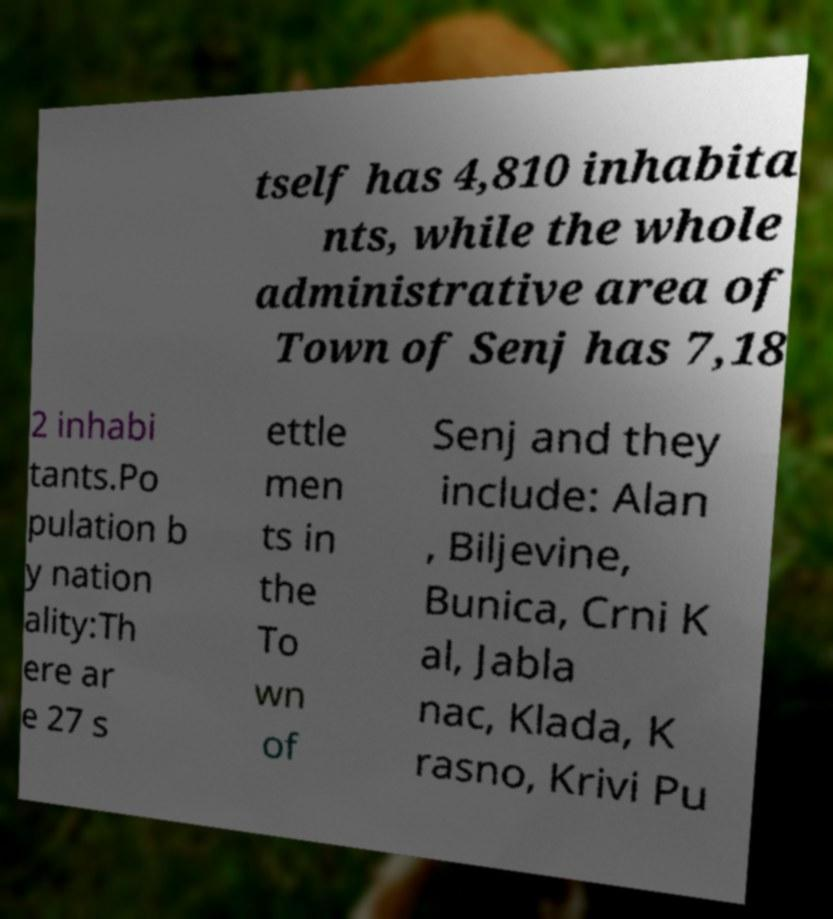Can you accurately transcribe the text from the provided image for me? tself has 4,810 inhabita nts, while the whole administrative area of Town of Senj has 7,18 2 inhabi tants.Po pulation b y nation ality:Th ere ar e 27 s ettle men ts in the To wn of Senj and they include: Alan , Biljevine, Bunica, Crni K al, Jabla nac, Klada, K rasno, Krivi Pu 